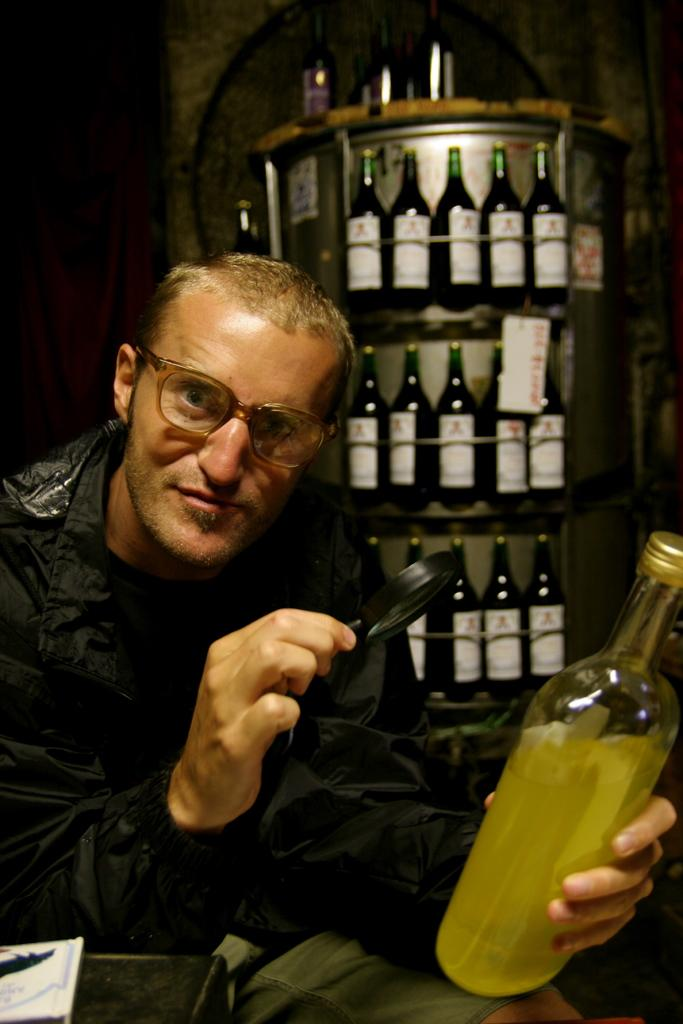Who is in the image? There is a man in the image. What is the man doing in the image? The man is examining a wine bottle. What tool is the man using to examine the wine bottle? The man is using a magnifying glass. What accessory is the man wearing in the image? The man wears spectacles. What can be seen in the background of the image? There are wine bottles placed in shelves in the background of the image. What type of berry is the man regretting in the image? There is no berry or regret present in the image; the man is examining a wine bottle using a magnifying glass. Can you tell me how many toads are on the shelves in the background of the image? There are no toads present in the image; the shelves in the background contain wine bottles. 